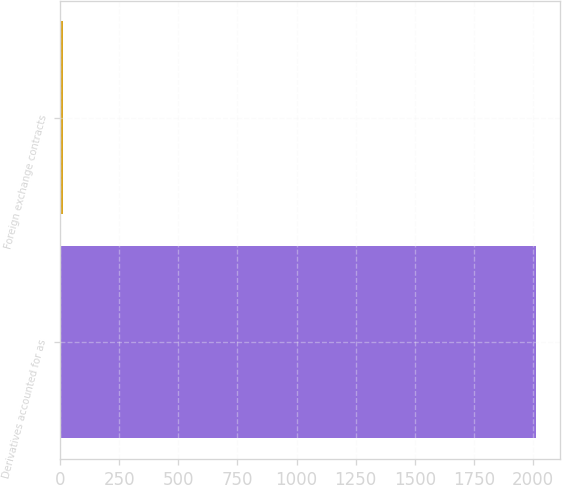Convert chart. <chart><loc_0><loc_0><loc_500><loc_500><bar_chart><fcel>Derivatives accounted for as<fcel>Foreign exchange contracts<nl><fcel>2014<fcel>14<nl></chart> 